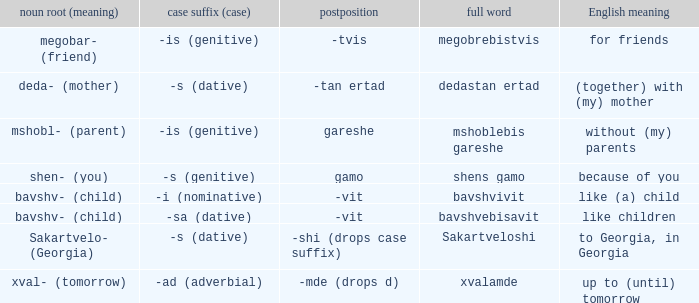What is Case Suffix (Case), when Postposition is "-mde (drops d)"? -ad (adverbial). 